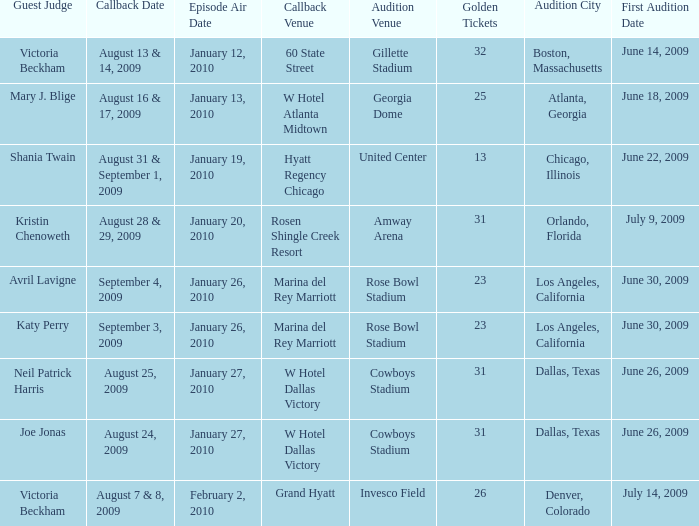Name the audition city for hyatt regency chicago Chicago, Illinois. 